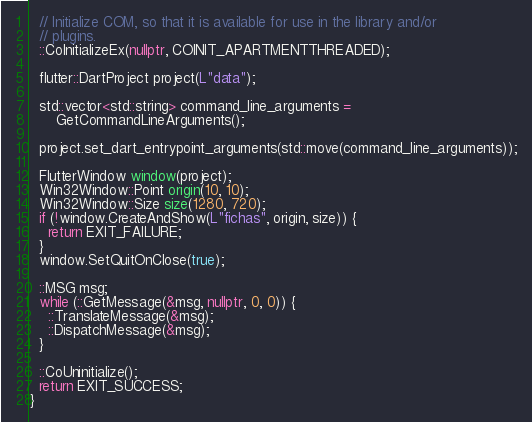Convert code to text. <code><loc_0><loc_0><loc_500><loc_500><_C++_>
  // Initialize COM, so that it is available for use in the library and/or
  // plugins.
  ::CoInitializeEx(nullptr, COINIT_APARTMENTTHREADED);

  flutter::DartProject project(L"data");

  std::vector<std::string> command_line_arguments =
      GetCommandLineArguments();

  project.set_dart_entrypoint_arguments(std::move(command_line_arguments));

  FlutterWindow window(project);
  Win32Window::Point origin(10, 10);
  Win32Window::Size size(1280, 720);
  if (!window.CreateAndShow(L"fichas", origin, size)) {
    return EXIT_FAILURE;
  }
  window.SetQuitOnClose(true);

  ::MSG msg;
  while (::GetMessage(&msg, nullptr, 0, 0)) {
    ::TranslateMessage(&msg);
    ::DispatchMessage(&msg);
  }

  ::CoUninitialize();
  return EXIT_SUCCESS;
}
</code> 